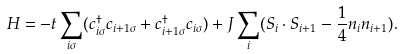Convert formula to latex. <formula><loc_0><loc_0><loc_500><loc_500>H = - t \sum _ { i \sigma } ( c _ { i \sigma } ^ { \dagger } c _ { i + 1 \sigma } + c _ { i + 1 \sigma } ^ { \dagger } c _ { i \sigma } ) + J \sum _ { i } ( { S } _ { i } \cdot { S } _ { i + 1 } - \frac { 1 } { 4 } n _ { i } n _ { i + 1 } ) .</formula> 